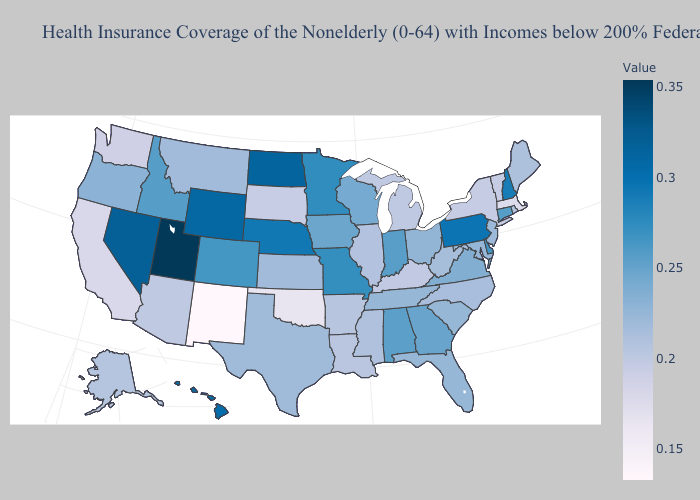Which states have the lowest value in the Northeast?
Keep it brief. Massachusetts. Among the states that border Kansas , does Missouri have the highest value?
Keep it brief. No. Does Connecticut have a higher value than Nevada?
Quick response, please. No. Which states have the lowest value in the MidWest?
Be succinct. South Dakota. Does the map have missing data?
Answer briefly. No. Does Vermont have the highest value in the USA?
Keep it brief. No. Does Alaska have the highest value in the USA?
Be succinct. No. Among the states that border South Dakota , which have the highest value?
Quick response, please. North Dakota. Does Arizona have a higher value than Ohio?
Concise answer only. No. 